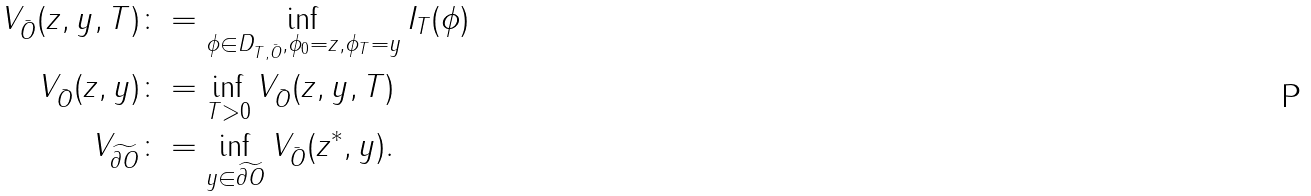<formula> <loc_0><loc_0><loc_500><loc_500>V _ { \bar { O } } ( z , y , T ) & \colon = \inf _ { \phi \in D _ { T , \bar { O } } , \phi _ { 0 } = z , \phi _ { T } = y } I _ { T } ( \phi ) \\ V _ { \bar { O } } ( z , y ) & \colon = \inf _ { T > 0 } V _ { \bar { O } } ( z , y , T ) \\ V _ { \widetilde { \partial O } } & \colon = \inf _ { y \in \widetilde { \partial O } } V _ { \bar { O } } ( z ^ { * } , y ) .</formula> 